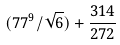<formula> <loc_0><loc_0><loc_500><loc_500>( 7 7 ^ { 9 } / \sqrt { 6 } ) + \frac { 3 1 4 } { 2 7 2 }</formula> 